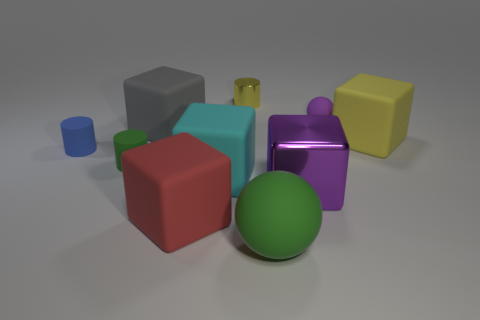Subtract all rubber cylinders. How many cylinders are left? 1 Subtract 1 blocks. How many blocks are left? 4 Subtract all yellow blocks. How many blocks are left? 4 Subtract all red blocks. Subtract all cyan balls. How many blocks are left? 4 Subtract all spheres. How many objects are left? 8 Add 5 cyan rubber cubes. How many cyan rubber cubes exist? 6 Subtract 0 cyan cylinders. How many objects are left? 10 Subtract all cyan rubber blocks. Subtract all cyan rubber objects. How many objects are left? 8 Add 7 small blue rubber cylinders. How many small blue rubber cylinders are left? 8 